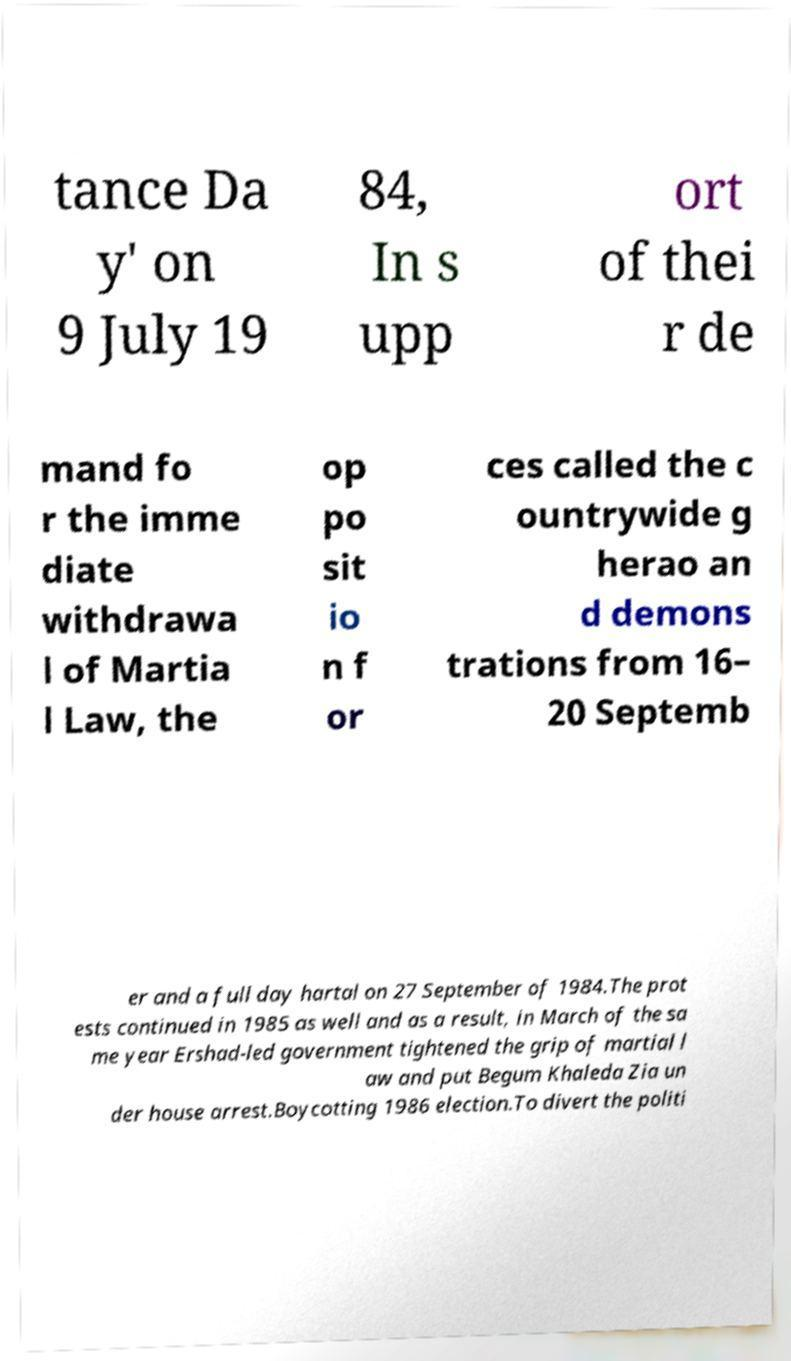I need the written content from this picture converted into text. Can you do that? tance Da y' on 9 July 19 84, In s upp ort of thei r de mand fo r the imme diate withdrawa l of Martia l Law, the op po sit io n f or ces called the c ountrywide g herao an d demons trations from 16– 20 Septemb er and a full day hartal on 27 September of 1984.The prot ests continued in 1985 as well and as a result, in March of the sa me year Ershad-led government tightened the grip of martial l aw and put Begum Khaleda Zia un der house arrest.Boycotting 1986 election.To divert the politi 